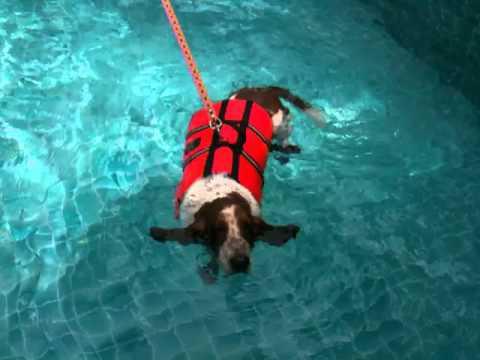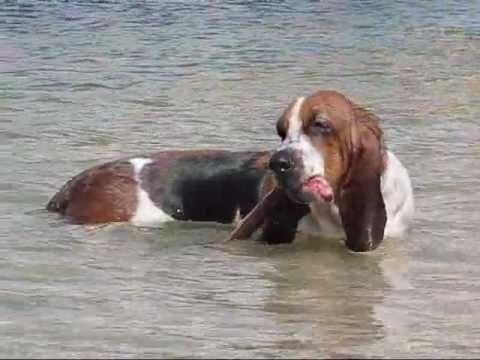The first image is the image on the left, the second image is the image on the right. Given the left and right images, does the statement "The dog in the image on the left is wearing a life jacket." hold true? Answer yes or no. Yes. The first image is the image on the left, the second image is the image on the right. Analyze the images presented: Is the assertion "A basset hound is wearing a bright red-orange life vest in a scene that contains water." valid? Answer yes or no. Yes. 